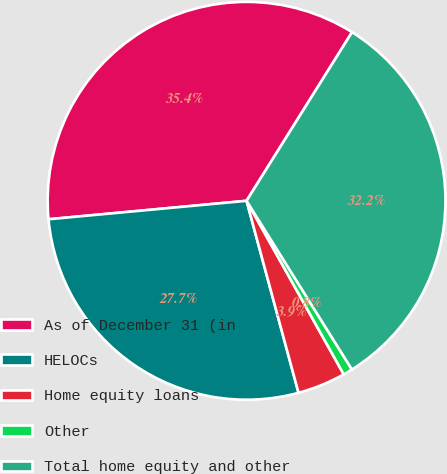<chart> <loc_0><loc_0><loc_500><loc_500><pie_chart><fcel>As of December 31 (in<fcel>HELOCs<fcel>Home equity loans<fcel>Other<fcel>Total home equity and other<nl><fcel>35.38%<fcel>27.73%<fcel>3.92%<fcel>0.76%<fcel>32.22%<nl></chart> 